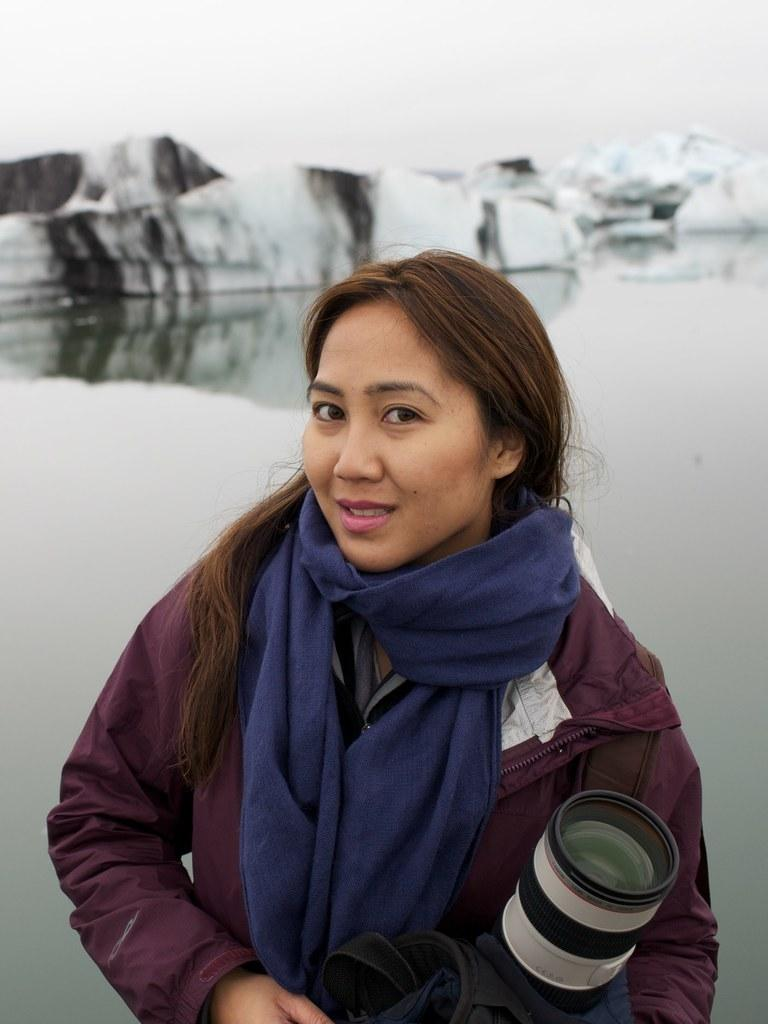Who is present in the image? There is a woman in the image. What is the woman holding in the image? The woman is holding a camera. What type of weather is depicted in the image? There is snow visible in the image, indicating a cold or wintry scene. What geographical features can be seen in the image? There are ice hills in the image. What else can be seen in the image besides the woman and the ice hills? There is water visible in the image, and the sky is also visible. Where is the shelf located in the image? There is no shelf present in the image. What type of polish is being applied to the ice hills in the image? There is no polish or any indication of polishing in the image; it depicts natural ice hills. 